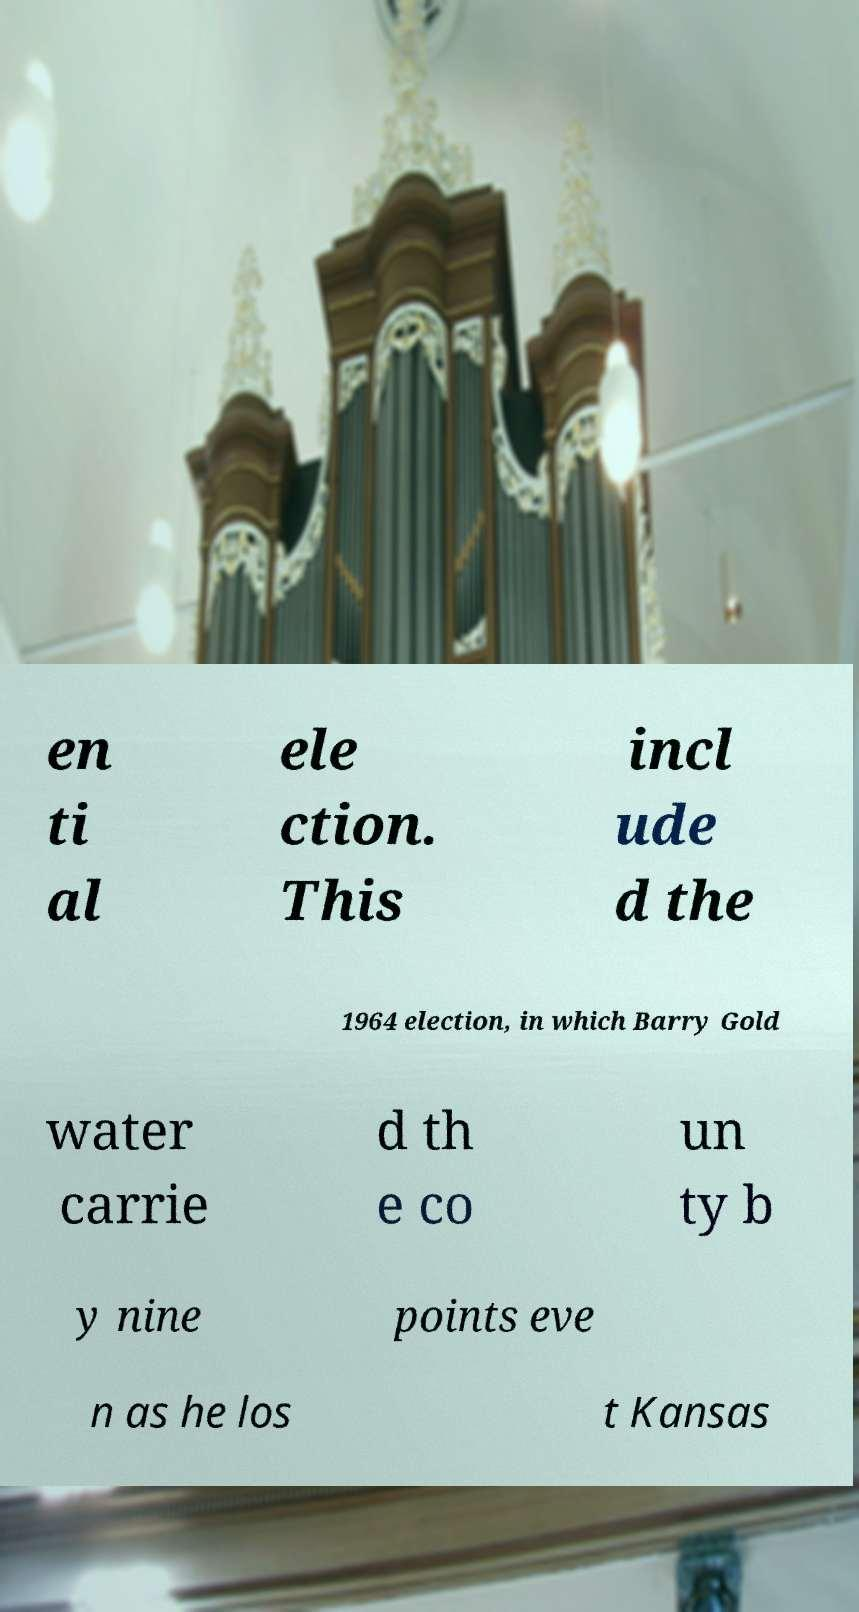Can you accurately transcribe the text from the provided image for me? en ti al ele ction. This incl ude d the 1964 election, in which Barry Gold water carrie d th e co un ty b y nine points eve n as he los t Kansas 